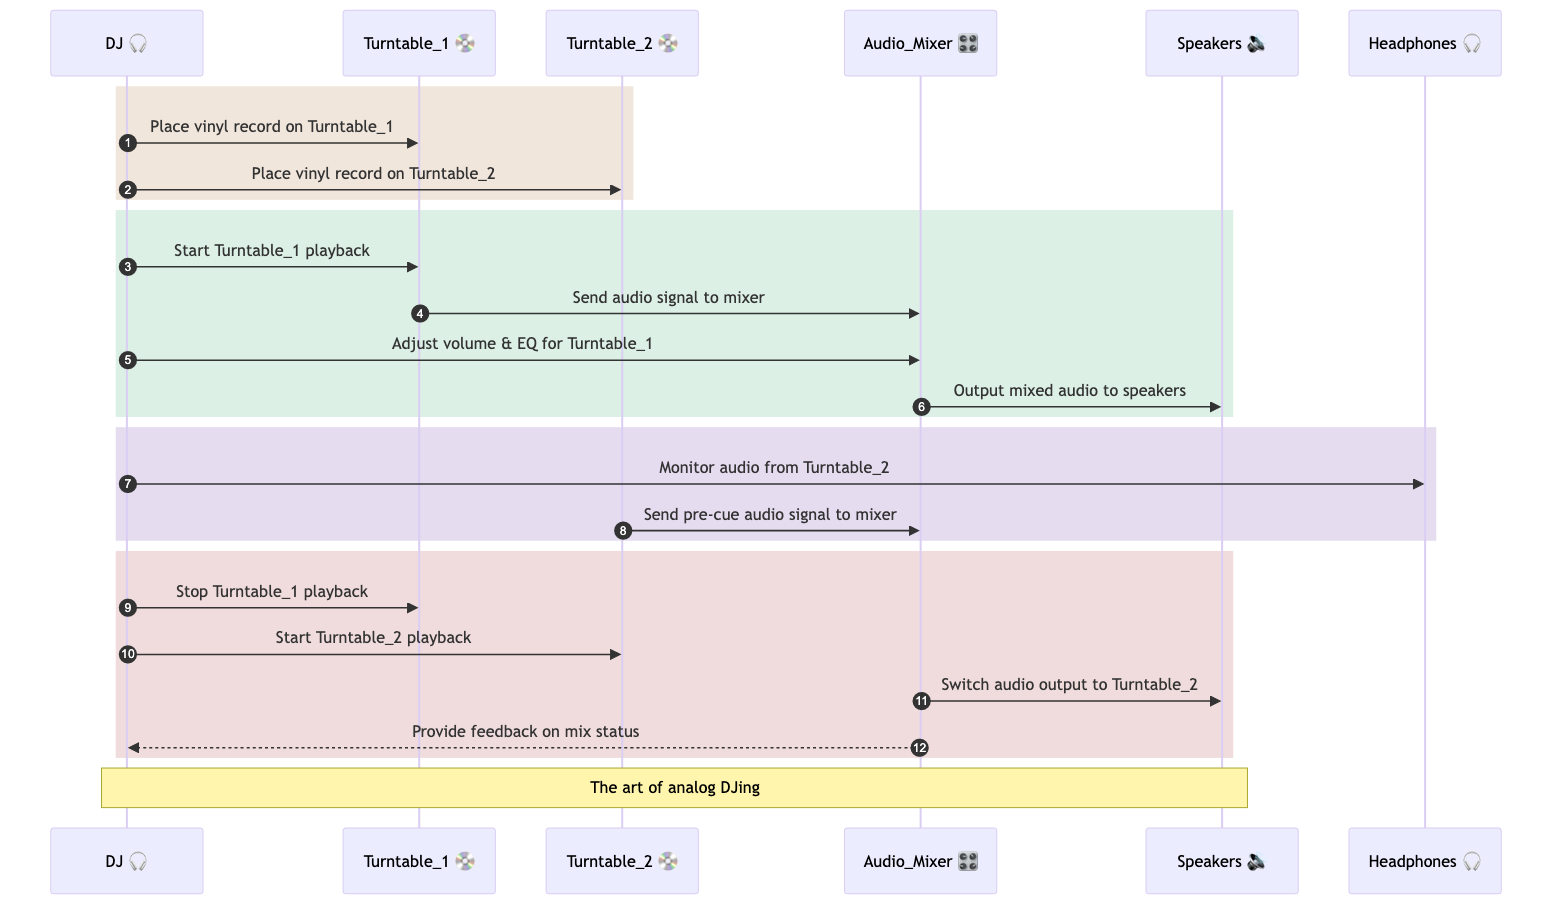What are the two turntables in the diagram? The diagram explicitly identifies two turntables by their names: "Turntable_1" and "Turntable_2". These are the key components for playback in this sequence.
Answer: Turntable_1, Turntable_2 How many participants are involved in the DJ booth setup? The diagram lists the following participants: DJ, Turntable_1, Turntable_2, Audio_Mixer, Speakers, and Headphones. Counting these gives a total of six participants.
Answer: 6 What happens after the DJ places a vinyl record on Turntable_1? After the DJ places a record on Turntable_1, the next action in the sequence is that the DJ starts Turntable_1 playback, leading to an audio signal being sent to the Audio Mixer.
Answer: Start Turntable_1 playback Which object provides feedback on mix status to the DJ? As per the diagram, the Audio Mixer is responsible for providing feedback on the mix status to the DJ following the actions related to playback and audio signal management.
Answer: Audio Mixer What action follows after the DJ adjusts volume and EQ for Turntable_1? The next action in the sequence is for the Audio Mixer to output mixed audio to the Speakers, indicating that the adjusted settings are being utilized for sound output.
Answer: Output mixed audio to speakers What is monitored by the DJ from Turntable_2? The DJ monitors the audio coming from Turntable_2 through the Headphones, allowing them to check the sound before it goes live through the speakers.
Answer: Audio from Turntable_2 Explain the sequence of actions that occur when switching from Turntable_1 to Turntable_2. Initially, the DJ stops Turntable_1 playback. Then, the DJ starts Turntable_2 playback, sending an audio signal to the Audio Mixer. Finally, the Audio Mixer switches the audio output to Turntable_2. Each step is dependent on the previous one to ensure a smooth transition.
Answer: Stop Turntable_1 playback, Start Turntable_2 playback, Switch audio output to Turntable_2 What is the final feedback provided in the diagram? The final line in the diagram notes that the Audio Mixer provides feedback to the DJ regarding the mix status, indicating that information exchange occurs at the end of the sequence after the switch.
Answer: Provide feedback on mix status What is the role of the Audio Mixer in the DJ's setup? The Audio Mixer acts as the central hub for controlling audio signals from the turntables, managing audio outputs, and mixing the sounds before sending them to the speakers.
Answer: Control audio signals from turntables 